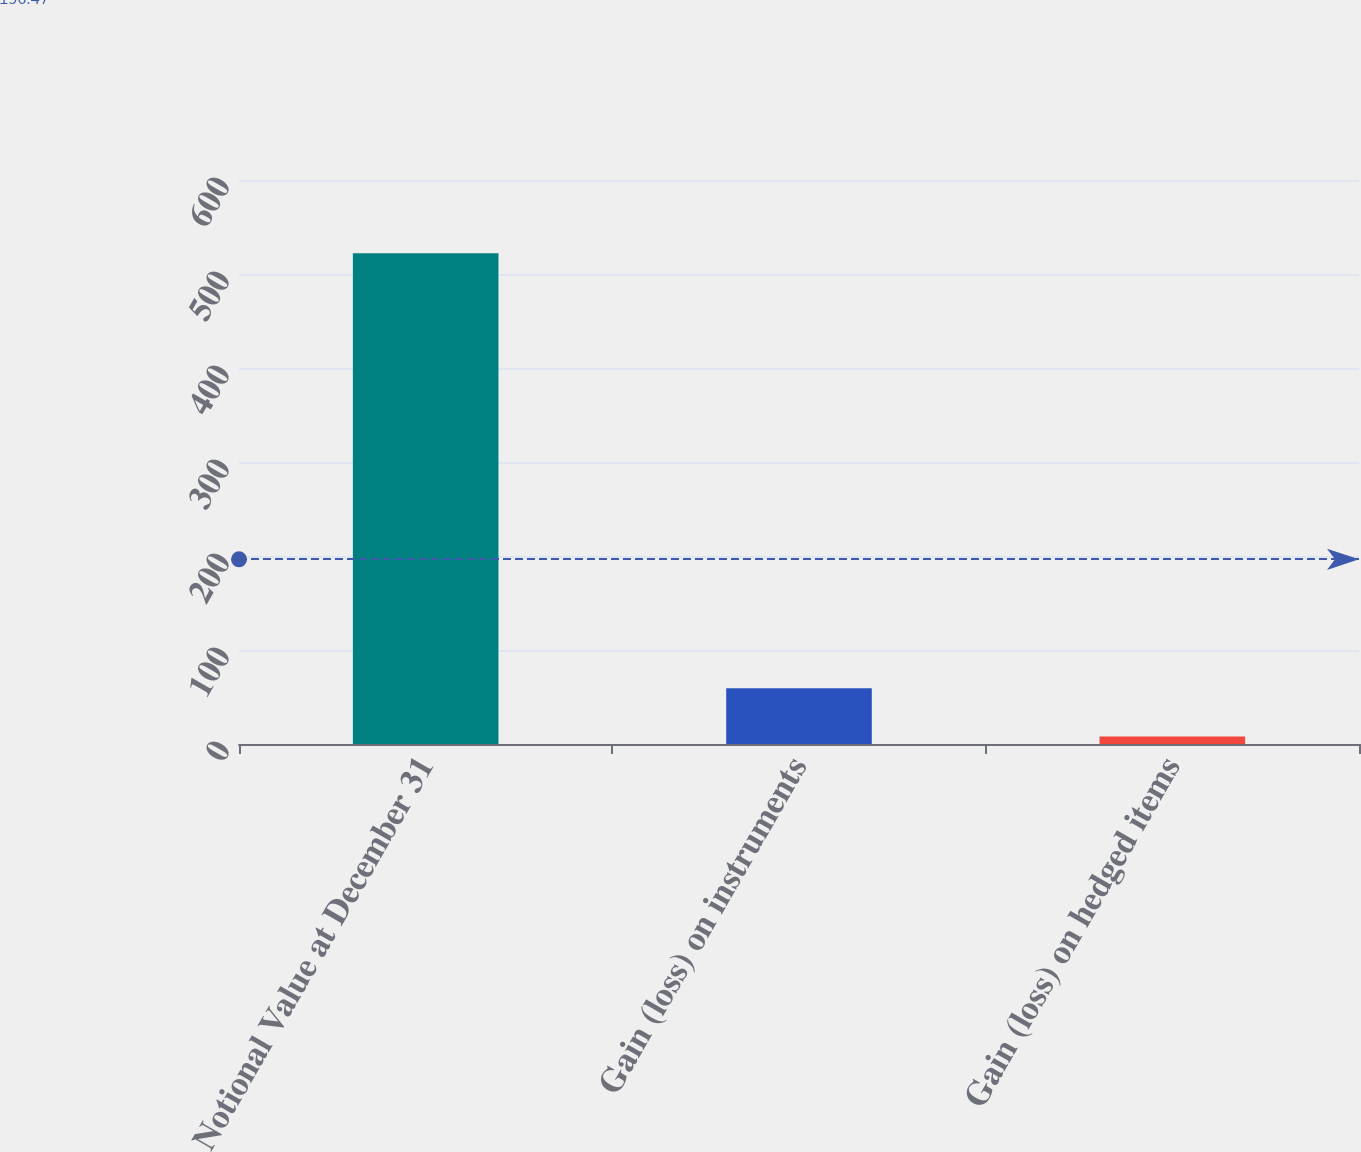Convert chart to OTSL. <chart><loc_0><loc_0><loc_500><loc_500><bar_chart><fcel>Notional Value at December 31<fcel>Gain (loss) on instruments<fcel>Gain (loss) on hedged items<nl><fcel>522<fcel>59.4<fcel>8<nl></chart> 